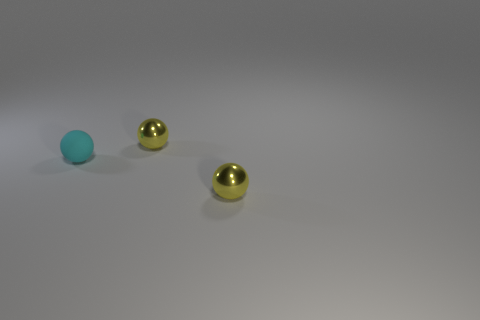How big is the ball in front of the small matte sphere?
Your answer should be compact. Small. What number of cyan rubber objects are in front of the tiny metal thing that is in front of the matte thing?
Provide a succinct answer. 0. What number of other objects are there of the same size as the matte ball?
Make the answer very short. 2. Does the shiny object in front of the cyan sphere have the same shape as the small matte object?
Provide a succinct answer. Yes. What number of tiny shiny things are both in front of the tiny cyan rubber thing and behind the matte thing?
Offer a terse response. 0. What is the cyan object made of?
Make the answer very short. Rubber. Are there any other things of the same color as the small matte ball?
Your response must be concise. No. How many small matte objects are on the left side of the tiny yellow metallic object behind the tiny shiny sphere in front of the tiny cyan sphere?
Offer a terse response. 1. How many matte things are there?
Your answer should be very brief. 1. Are there fewer tiny balls behind the rubber thing than balls?
Your answer should be compact. Yes. 